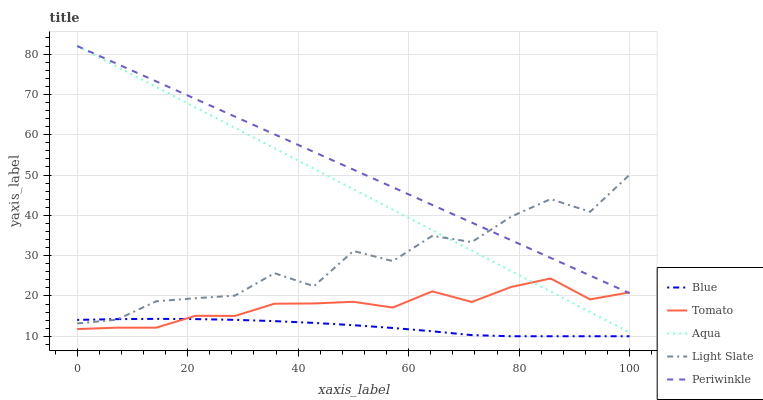Does Blue have the minimum area under the curve?
Answer yes or no. Yes. Does Periwinkle have the maximum area under the curve?
Answer yes or no. Yes. Does Tomato have the minimum area under the curve?
Answer yes or no. No. Does Tomato have the maximum area under the curve?
Answer yes or no. No. Is Aqua the smoothest?
Answer yes or no. Yes. Is Light Slate the roughest?
Answer yes or no. Yes. Is Tomato the smoothest?
Answer yes or no. No. Is Tomato the roughest?
Answer yes or no. No. Does Blue have the lowest value?
Answer yes or no. Yes. Does Tomato have the lowest value?
Answer yes or no. No. Does Aqua have the highest value?
Answer yes or no. Yes. Does Tomato have the highest value?
Answer yes or no. No. Is Blue less than Aqua?
Answer yes or no. Yes. Is Light Slate greater than Tomato?
Answer yes or no. Yes. Does Periwinkle intersect Tomato?
Answer yes or no. Yes. Is Periwinkle less than Tomato?
Answer yes or no. No. Is Periwinkle greater than Tomato?
Answer yes or no. No. Does Blue intersect Aqua?
Answer yes or no. No. 